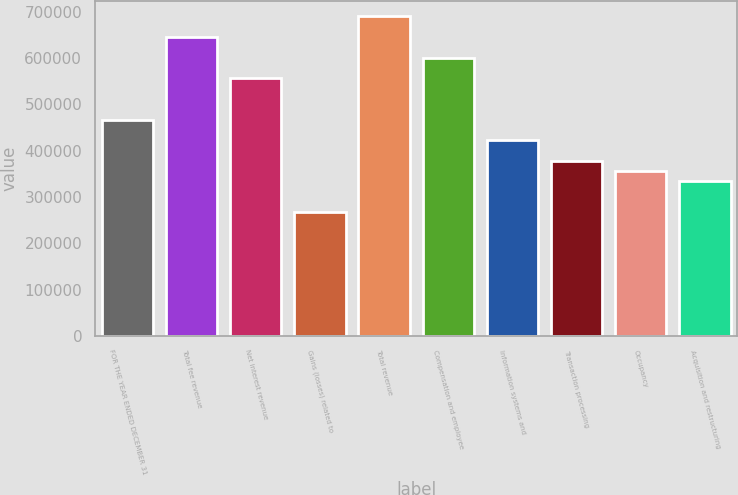Convert chart to OTSL. <chart><loc_0><loc_0><loc_500><loc_500><bar_chart><fcel>FOR THE YEAR ENDED DECEMBER 31<fcel>Total fee revenue<fcel>Net interest revenue<fcel>Gains (losses) related to<fcel>Total revenue<fcel>Compensation and employee<fcel>Information systems and<fcel>Transaction processing<fcel>Occupancy<fcel>Acquisition and restructuring<nl><fcel>467421<fcel>645486<fcel>556453<fcel>267098<fcel>690002<fcel>600970<fcel>422905<fcel>378389<fcel>356131<fcel>333872<nl></chart> 